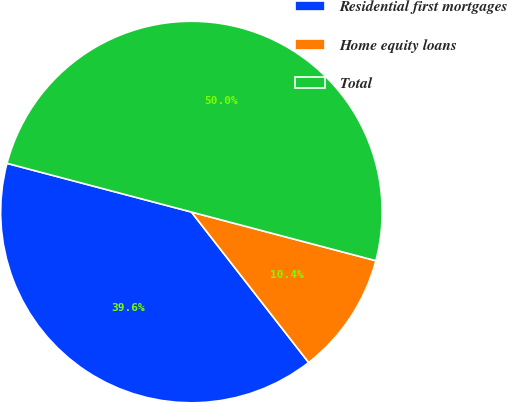<chart> <loc_0><loc_0><loc_500><loc_500><pie_chart><fcel>Residential first mortgages<fcel>Home equity loans<fcel>Total<nl><fcel>39.64%<fcel>10.36%<fcel>50.0%<nl></chart> 